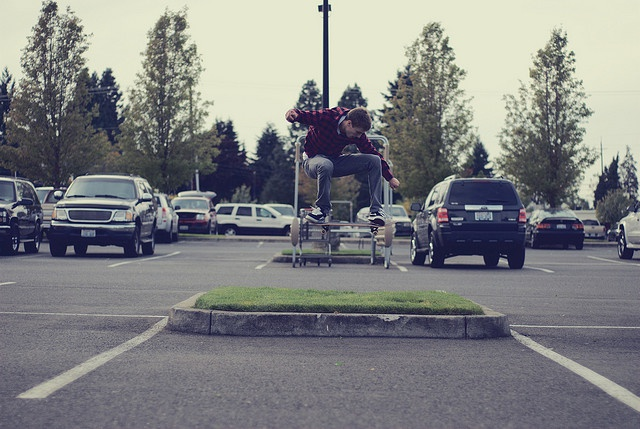Describe the objects in this image and their specific colors. I can see car in beige, navy, gray, and darkgray tones, car in beige, navy, darkgray, and gray tones, people in beige, navy, gray, and darkgray tones, car in beige, navy, gray, and darkgray tones, and car in beige, darkgray, gray, and navy tones in this image. 